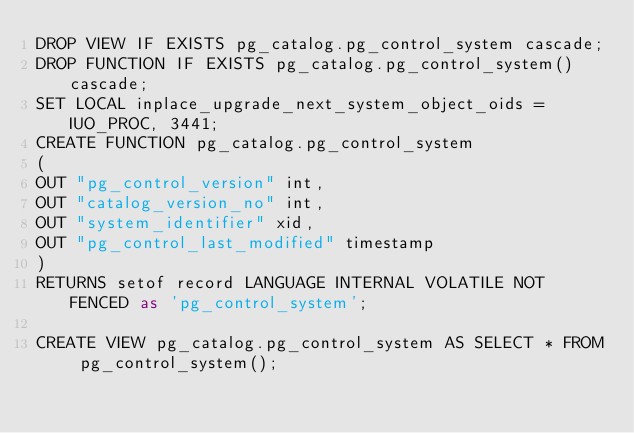<code> <loc_0><loc_0><loc_500><loc_500><_SQL_>DROP VIEW IF EXISTS pg_catalog.pg_control_system cascade;
DROP FUNCTION IF EXISTS pg_catalog.pg_control_system() cascade;
SET LOCAL inplace_upgrade_next_system_object_oids = IUO_PROC, 3441;
CREATE FUNCTION pg_catalog.pg_control_system
(
OUT "pg_control_version" int,
OUT "catalog_version_no" int,
OUT "system_identifier" xid,
OUT "pg_control_last_modified" timestamp
)
RETURNS setof record LANGUAGE INTERNAL VOLATILE NOT FENCED as 'pg_control_system';

CREATE VIEW pg_catalog.pg_control_system AS SELECT * FROM pg_control_system();
</code> 